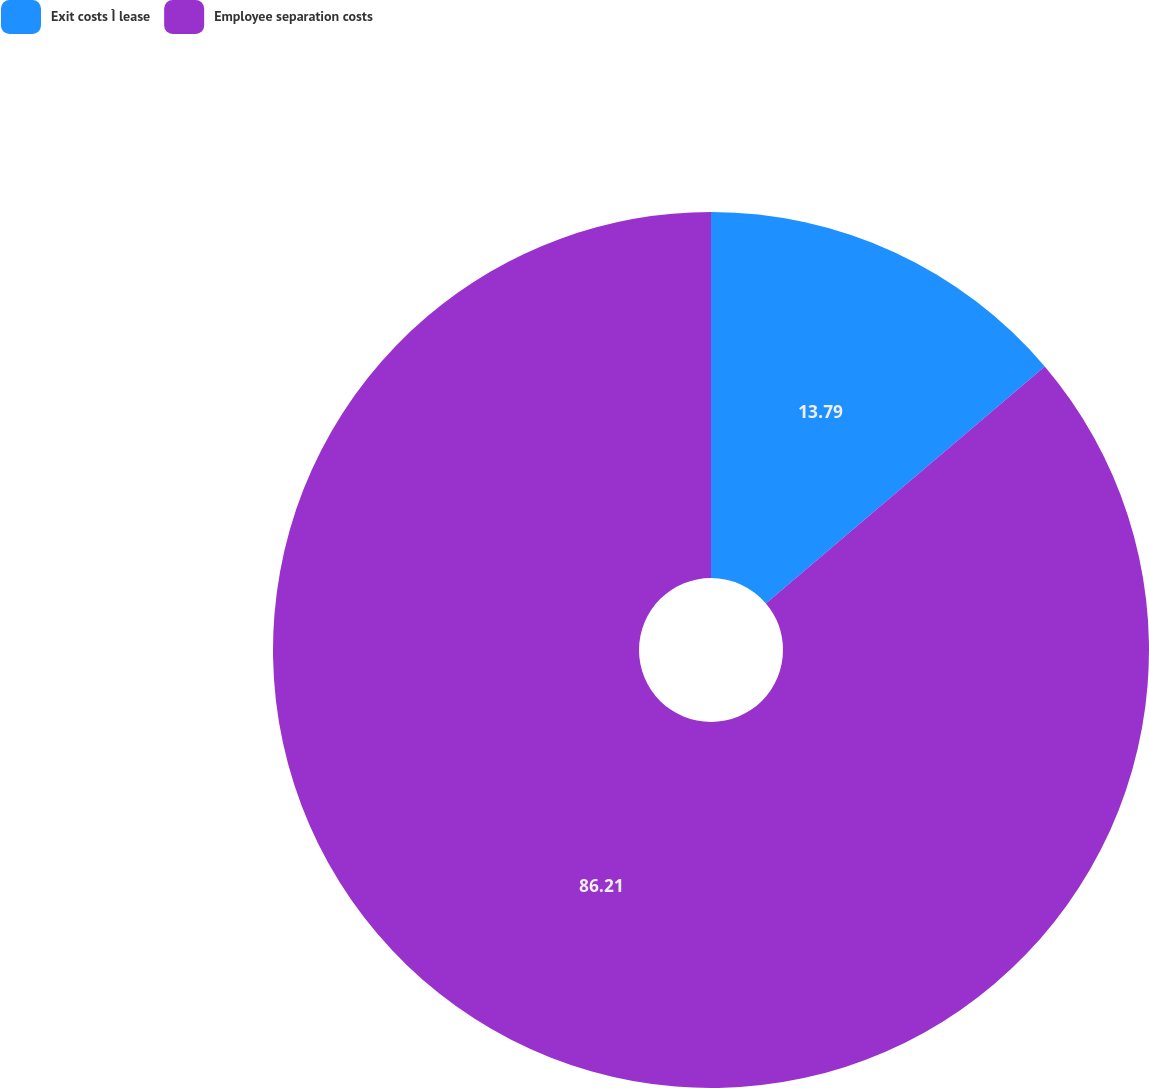Convert chart. <chart><loc_0><loc_0><loc_500><loc_500><pie_chart><fcel>Exit costs Ì lease<fcel>Employee separation costs<nl><fcel>13.79%<fcel>86.21%<nl></chart> 